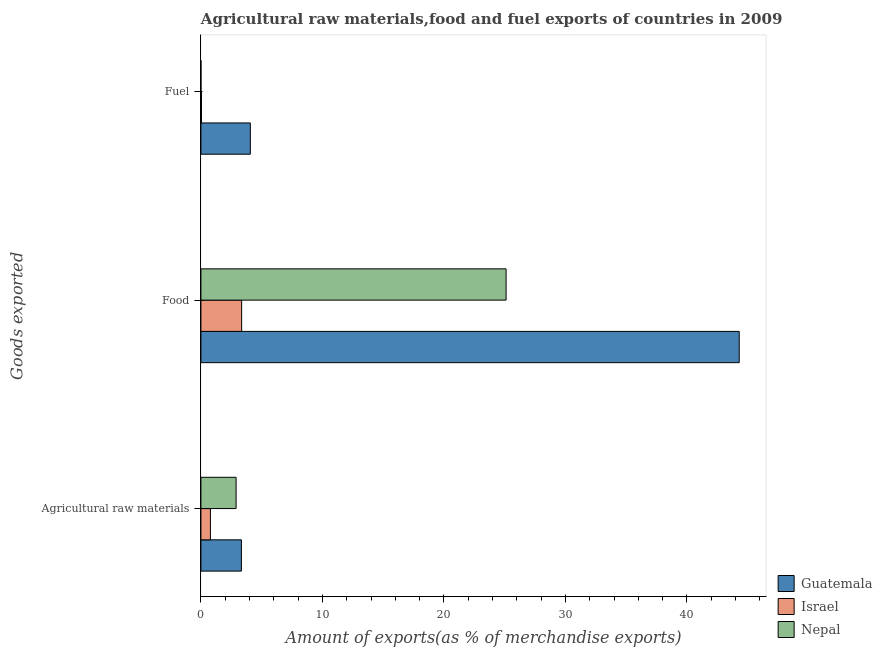How many different coloured bars are there?
Give a very brief answer. 3. How many groups of bars are there?
Make the answer very short. 3. What is the label of the 2nd group of bars from the top?
Provide a short and direct response. Food. What is the percentage of raw materials exports in Nepal?
Give a very brief answer. 2.89. Across all countries, what is the maximum percentage of raw materials exports?
Keep it short and to the point. 3.33. Across all countries, what is the minimum percentage of food exports?
Your answer should be very brief. 3.35. In which country was the percentage of raw materials exports maximum?
Your answer should be compact. Guatemala. In which country was the percentage of fuel exports minimum?
Provide a short and direct response. Nepal. What is the total percentage of fuel exports in the graph?
Offer a terse response. 4.12. What is the difference between the percentage of raw materials exports in Nepal and that in Israel?
Ensure brevity in your answer.  2.11. What is the difference between the percentage of food exports in Nepal and the percentage of raw materials exports in Israel?
Provide a short and direct response. 24.33. What is the average percentage of food exports per country?
Your answer should be compact. 24.26. What is the difference between the percentage of fuel exports and percentage of raw materials exports in Israel?
Your answer should be compact. -0.73. In how many countries, is the percentage of raw materials exports greater than 18 %?
Provide a short and direct response. 0. What is the ratio of the percentage of fuel exports in Guatemala to that in Israel?
Keep it short and to the point. 86.57. What is the difference between the highest and the second highest percentage of fuel exports?
Your answer should be compact. 4.02. What is the difference between the highest and the lowest percentage of fuel exports?
Your answer should be compact. 4.06. In how many countries, is the percentage of raw materials exports greater than the average percentage of raw materials exports taken over all countries?
Provide a short and direct response. 2. Is the sum of the percentage of fuel exports in Nepal and Israel greater than the maximum percentage of food exports across all countries?
Offer a terse response. No. What does the 1st bar from the top in Food represents?
Offer a very short reply. Nepal. What does the 3rd bar from the bottom in Agricultural raw materials represents?
Give a very brief answer. Nepal. Are all the bars in the graph horizontal?
Make the answer very short. Yes. How many countries are there in the graph?
Offer a very short reply. 3. What is the difference between two consecutive major ticks on the X-axis?
Provide a short and direct response. 10. Does the graph contain any zero values?
Offer a very short reply. No. Does the graph contain grids?
Make the answer very short. No. Where does the legend appear in the graph?
Ensure brevity in your answer.  Bottom right. How are the legend labels stacked?
Your answer should be very brief. Vertical. What is the title of the graph?
Your answer should be very brief. Agricultural raw materials,food and fuel exports of countries in 2009. Does "Costa Rica" appear as one of the legend labels in the graph?
Give a very brief answer. No. What is the label or title of the X-axis?
Ensure brevity in your answer.  Amount of exports(as % of merchandise exports). What is the label or title of the Y-axis?
Ensure brevity in your answer.  Goods exported. What is the Amount of exports(as % of merchandise exports) in Guatemala in Agricultural raw materials?
Offer a very short reply. 3.33. What is the Amount of exports(as % of merchandise exports) in Israel in Agricultural raw materials?
Ensure brevity in your answer.  0.78. What is the Amount of exports(as % of merchandise exports) in Nepal in Agricultural raw materials?
Your response must be concise. 2.89. What is the Amount of exports(as % of merchandise exports) in Guatemala in Food?
Keep it short and to the point. 44.3. What is the Amount of exports(as % of merchandise exports) in Israel in Food?
Provide a succinct answer. 3.35. What is the Amount of exports(as % of merchandise exports) in Nepal in Food?
Your answer should be compact. 25.11. What is the Amount of exports(as % of merchandise exports) in Guatemala in Fuel?
Provide a short and direct response. 4.07. What is the Amount of exports(as % of merchandise exports) of Israel in Fuel?
Provide a short and direct response. 0.05. What is the Amount of exports(as % of merchandise exports) in Nepal in Fuel?
Offer a very short reply. 0. Across all Goods exported, what is the maximum Amount of exports(as % of merchandise exports) in Guatemala?
Provide a succinct answer. 44.3. Across all Goods exported, what is the maximum Amount of exports(as % of merchandise exports) in Israel?
Your answer should be compact. 3.35. Across all Goods exported, what is the maximum Amount of exports(as % of merchandise exports) of Nepal?
Your response must be concise. 25.11. Across all Goods exported, what is the minimum Amount of exports(as % of merchandise exports) in Guatemala?
Offer a very short reply. 3.33. Across all Goods exported, what is the minimum Amount of exports(as % of merchandise exports) in Israel?
Ensure brevity in your answer.  0.05. Across all Goods exported, what is the minimum Amount of exports(as % of merchandise exports) of Nepal?
Your answer should be compact. 0. What is the total Amount of exports(as % of merchandise exports) of Guatemala in the graph?
Make the answer very short. 51.7. What is the total Amount of exports(as % of merchandise exports) in Israel in the graph?
Ensure brevity in your answer.  4.18. What is the total Amount of exports(as % of merchandise exports) of Nepal in the graph?
Offer a very short reply. 28.01. What is the difference between the Amount of exports(as % of merchandise exports) of Guatemala in Agricultural raw materials and that in Food?
Make the answer very short. -40.97. What is the difference between the Amount of exports(as % of merchandise exports) in Israel in Agricultural raw materials and that in Food?
Make the answer very short. -2.57. What is the difference between the Amount of exports(as % of merchandise exports) in Nepal in Agricultural raw materials and that in Food?
Make the answer very short. -22.22. What is the difference between the Amount of exports(as % of merchandise exports) of Guatemala in Agricultural raw materials and that in Fuel?
Ensure brevity in your answer.  -0.73. What is the difference between the Amount of exports(as % of merchandise exports) of Israel in Agricultural raw materials and that in Fuel?
Your response must be concise. 0.73. What is the difference between the Amount of exports(as % of merchandise exports) in Nepal in Agricultural raw materials and that in Fuel?
Your answer should be very brief. 2.89. What is the difference between the Amount of exports(as % of merchandise exports) of Guatemala in Food and that in Fuel?
Your answer should be very brief. 40.23. What is the difference between the Amount of exports(as % of merchandise exports) in Israel in Food and that in Fuel?
Keep it short and to the point. 3.3. What is the difference between the Amount of exports(as % of merchandise exports) in Nepal in Food and that in Fuel?
Your answer should be very brief. 25.11. What is the difference between the Amount of exports(as % of merchandise exports) in Guatemala in Agricultural raw materials and the Amount of exports(as % of merchandise exports) in Israel in Food?
Your answer should be very brief. -0.02. What is the difference between the Amount of exports(as % of merchandise exports) of Guatemala in Agricultural raw materials and the Amount of exports(as % of merchandise exports) of Nepal in Food?
Give a very brief answer. -21.78. What is the difference between the Amount of exports(as % of merchandise exports) of Israel in Agricultural raw materials and the Amount of exports(as % of merchandise exports) of Nepal in Food?
Provide a succinct answer. -24.33. What is the difference between the Amount of exports(as % of merchandise exports) in Guatemala in Agricultural raw materials and the Amount of exports(as % of merchandise exports) in Israel in Fuel?
Give a very brief answer. 3.29. What is the difference between the Amount of exports(as % of merchandise exports) in Guatemala in Agricultural raw materials and the Amount of exports(as % of merchandise exports) in Nepal in Fuel?
Offer a very short reply. 3.33. What is the difference between the Amount of exports(as % of merchandise exports) in Israel in Agricultural raw materials and the Amount of exports(as % of merchandise exports) in Nepal in Fuel?
Your answer should be compact. 0.78. What is the difference between the Amount of exports(as % of merchandise exports) in Guatemala in Food and the Amount of exports(as % of merchandise exports) in Israel in Fuel?
Your response must be concise. 44.25. What is the difference between the Amount of exports(as % of merchandise exports) of Guatemala in Food and the Amount of exports(as % of merchandise exports) of Nepal in Fuel?
Your response must be concise. 44.3. What is the difference between the Amount of exports(as % of merchandise exports) of Israel in Food and the Amount of exports(as % of merchandise exports) of Nepal in Fuel?
Give a very brief answer. 3.35. What is the average Amount of exports(as % of merchandise exports) of Guatemala per Goods exported?
Provide a succinct answer. 17.23. What is the average Amount of exports(as % of merchandise exports) in Israel per Goods exported?
Provide a succinct answer. 1.39. What is the average Amount of exports(as % of merchandise exports) in Nepal per Goods exported?
Provide a succinct answer. 9.34. What is the difference between the Amount of exports(as % of merchandise exports) in Guatemala and Amount of exports(as % of merchandise exports) in Israel in Agricultural raw materials?
Give a very brief answer. 2.55. What is the difference between the Amount of exports(as % of merchandise exports) in Guatemala and Amount of exports(as % of merchandise exports) in Nepal in Agricultural raw materials?
Your answer should be compact. 0.44. What is the difference between the Amount of exports(as % of merchandise exports) in Israel and Amount of exports(as % of merchandise exports) in Nepal in Agricultural raw materials?
Ensure brevity in your answer.  -2.11. What is the difference between the Amount of exports(as % of merchandise exports) of Guatemala and Amount of exports(as % of merchandise exports) of Israel in Food?
Offer a terse response. 40.95. What is the difference between the Amount of exports(as % of merchandise exports) in Guatemala and Amount of exports(as % of merchandise exports) in Nepal in Food?
Offer a terse response. 19.18. What is the difference between the Amount of exports(as % of merchandise exports) in Israel and Amount of exports(as % of merchandise exports) in Nepal in Food?
Provide a short and direct response. -21.76. What is the difference between the Amount of exports(as % of merchandise exports) in Guatemala and Amount of exports(as % of merchandise exports) in Israel in Fuel?
Keep it short and to the point. 4.02. What is the difference between the Amount of exports(as % of merchandise exports) in Guatemala and Amount of exports(as % of merchandise exports) in Nepal in Fuel?
Keep it short and to the point. 4.06. What is the difference between the Amount of exports(as % of merchandise exports) of Israel and Amount of exports(as % of merchandise exports) of Nepal in Fuel?
Offer a terse response. 0.05. What is the ratio of the Amount of exports(as % of merchandise exports) of Guatemala in Agricultural raw materials to that in Food?
Your answer should be compact. 0.08. What is the ratio of the Amount of exports(as % of merchandise exports) of Israel in Agricultural raw materials to that in Food?
Your answer should be very brief. 0.23. What is the ratio of the Amount of exports(as % of merchandise exports) in Nepal in Agricultural raw materials to that in Food?
Make the answer very short. 0.12. What is the ratio of the Amount of exports(as % of merchandise exports) in Guatemala in Agricultural raw materials to that in Fuel?
Ensure brevity in your answer.  0.82. What is the ratio of the Amount of exports(as % of merchandise exports) of Israel in Agricultural raw materials to that in Fuel?
Provide a short and direct response. 16.64. What is the ratio of the Amount of exports(as % of merchandise exports) in Nepal in Agricultural raw materials to that in Fuel?
Your answer should be compact. 1715.45. What is the ratio of the Amount of exports(as % of merchandise exports) in Guatemala in Food to that in Fuel?
Your answer should be very brief. 10.89. What is the ratio of the Amount of exports(as % of merchandise exports) of Israel in Food to that in Fuel?
Offer a very short reply. 71.35. What is the ratio of the Amount of exports(as % of merchandise exports) of Nepal in Food to that in Fuel?
Offer a very short reply. 1.49e+04. What is the difference between the highest and the second highest Amount of exports(as % of merchandise exports) in Guatemala?
Offer a terse response. 40.23. What is the difference between the highest and the second highest Amount of exports(as % of merchandise exports) of Israel?
Provide a short and direct response. 2.57. What is the difference between the highest and the second highest Amount of exports(as % of merchandise exports) in Nepal?
Offer a terse response. 22.22. What is the difference between the highest and the lowest Amount of exports(as % of merchandise exports) of Guatemala?
Provide a succinct answer. 40.97. What is the difference between the highest and the lowest Amount of exports(as % of merchandise exports) in Israel?
Offer a terse response. 3.3. What is the difference between the highest and the lowest Amount of exports(as % of merchandise exports) of Nepal?
Give a very brief answer. 25.11. 